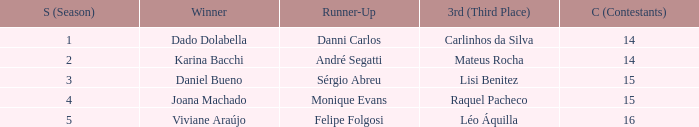How many contestants were there when the runner-up was Monique Evans? 15.0. 